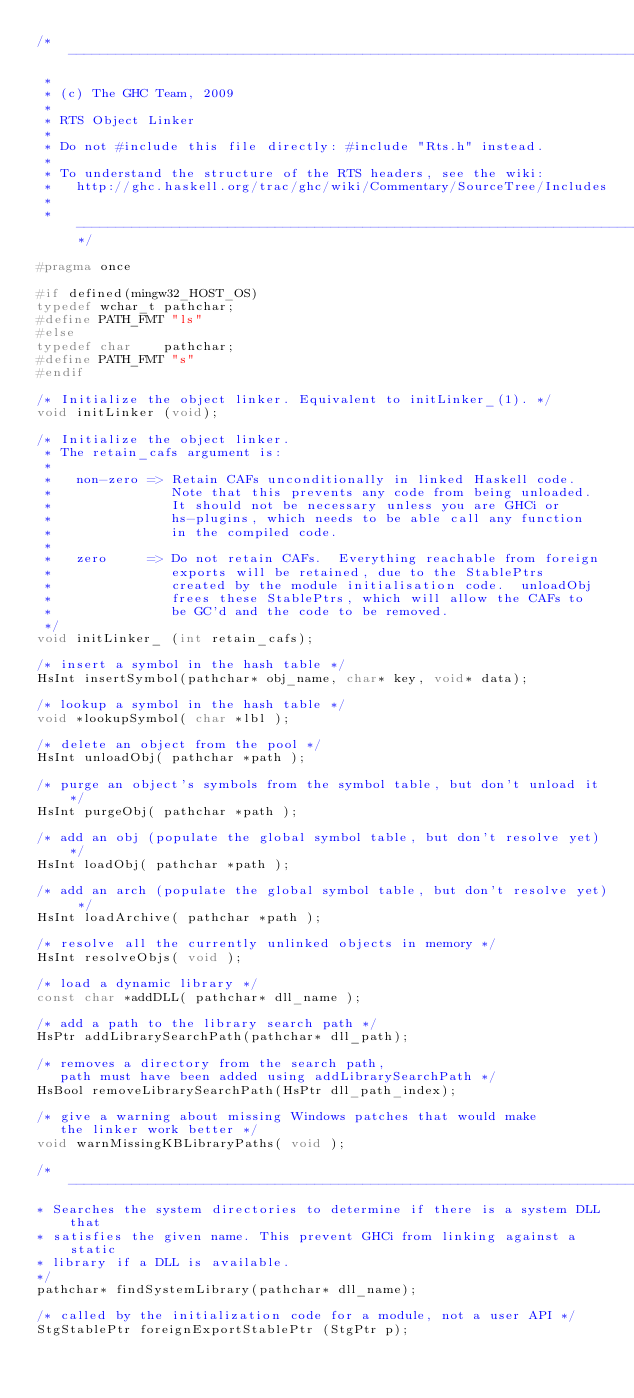Convert code to text. <code><loc_0><loc_0><loc_500><loc_500><_C_>/* -----------------------------------------------------------------------------
 *
 * (c) The GHC Team, 2009
 *
 * RTS Object Linker
 *
 * Do not #include this file directly: #include "Rts.h" instead.
 *
 * To understand the structure of the RTS headers, see the wiki:
 *   http://ghc.haskell.org/trac/ghc/wiki/Commentary/SourceTree/Includes
 *
 * ---------------------------------------------------------------------------*/

#pragma once

#if defined(mingw32_HOST_OS)
typedef wchar_t pathchar;
#define PATH_FMT "ls"
#else
typedef char    pathchar;
#define PATH_FMT "s"
#endif

/* Initialize the object linker. Equivalent to initLinker_(1). */
void initLinker (void);

/* Initialize the object linker.
 * The retain_cafs argument is:
 *
 *   non-zero => Retain CAFs unconditionally in linked Haskell code.
 *               Note that this prevents any code from being unloaded.
 *               It should not be necessary unless you are GHCi or
 *               hs-plugins, which needs to be able call any function
 *               in the compiled code.
 *
 *   zero     => Do not retain CAFs.  Everything reachable from foreign
 *               exports will be retained, due to the StablePtrs
 *               created by the module initialisation code.  unloadObj
 *               frees these StablePtrs, which will allow the CAFs to
 *               be GC'd and the code to be removed.
 */
void initLinker_ (int retain_cafs);

/* insert a symbol in the hash table */
HsInt insertSymbol(pathchar* obj_name, char* key, void* data);

/* lookup a symbol in the hash table */
void *lookupSymbol( char *lbl );

/* delete an object from the pool */
HsInt unloadObj( pathchar *path );

/* purge an object's symbols from the symbol table, but don't unload it */
HsInt purgeObj( pathchar *path );

/* add an obj (populate the global symbol table, but don't resolve yet) */
HsInt loadObj( pathchar *path );

/* add an arch (populate the global symbol table, but don't resolve yet) */
HsInt loadArchive( pathchar *path );

/* resolve all the currently unlinked objects in memory */
HsInt resolveObjs( void );

/* load a dynamic library */
const char *addDLL( pathchar* dll_name );

/* add a path to the library search path */
HsPtr addLibrarySearchPath(pathchar* dll_path);

/* removes a directory from the search path,
   path must have been added using addLibrarySearchPath */
HsBool removeLibrarySearchPath(HsPtr dll_path_index);

/* give a warning about missing Windows patches that would make
   the linker work better */
void warnMissingKBLibraryPaths( void );

/* -----------------------------------------------------------------------------
* Searches the system directories to determine if there is a system DLL that
* satisfies the given name. This prevent GHCi from linking against a static
* library if a DLL is available.
*/
pathchar* findSystemLibrary(pathchar* dll_name);

/* called by the initialization code for a module, not a user API */
StgStablePtr foreignExportStablePtr (StgPtr p);
</code> 